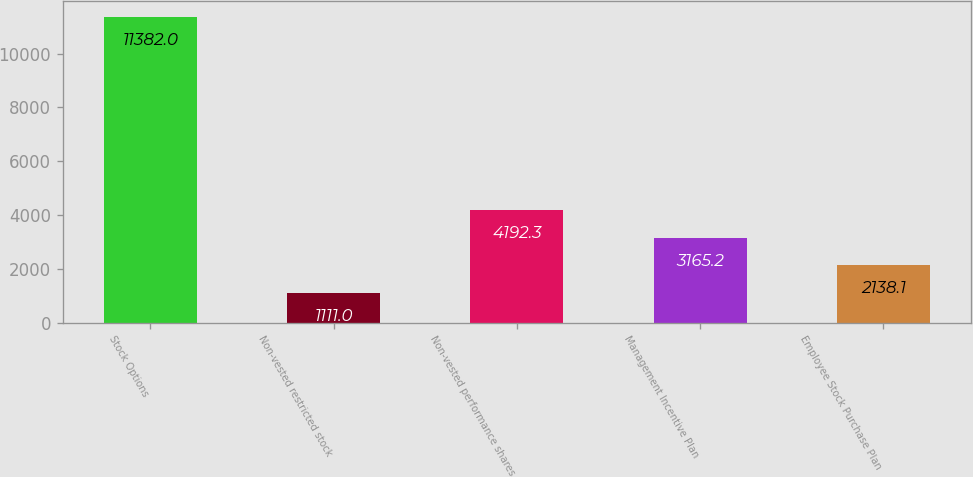Convert chart. <chart><loc_0><loc_0><loc_500><loc_500><bar_chart><fcel>Stock Options<fcel>Non-vested restricted stock<fcel>Non-vested performance shares<fcel>Management Incentive Plan<fcel>Employee Stock Purchase Plan<nl><fcel>11382<fcel>1111<fcel>4192.3<fcel>3165.2<fcel>2138.1<nl></chart> 